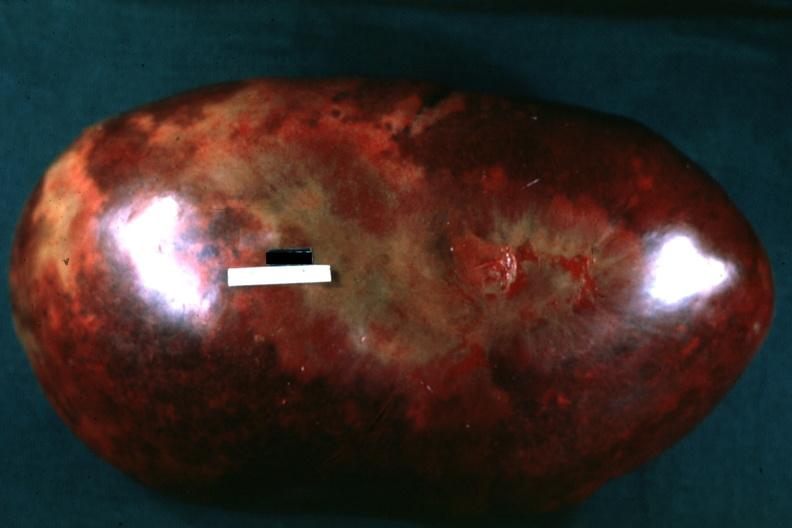s chronic myelogenous leukemia present?
Answer the question using a single word or phrase. Yes 